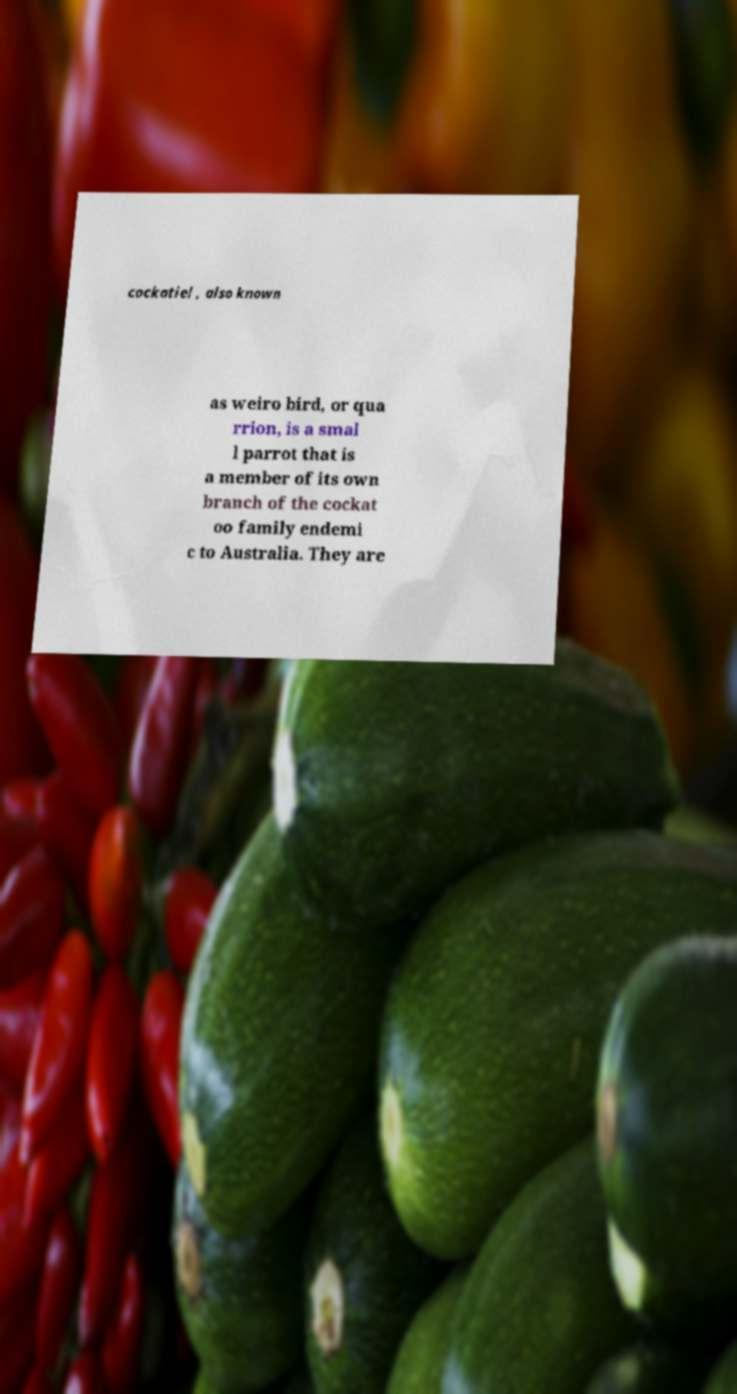I need the written content from this picture converted into text. Can you do that? cockatiel , also known as weiro bird, or qua rrion, is a smal l parrot that is a member of its own branch of the cockat oo family endemi c to Australia. They are 